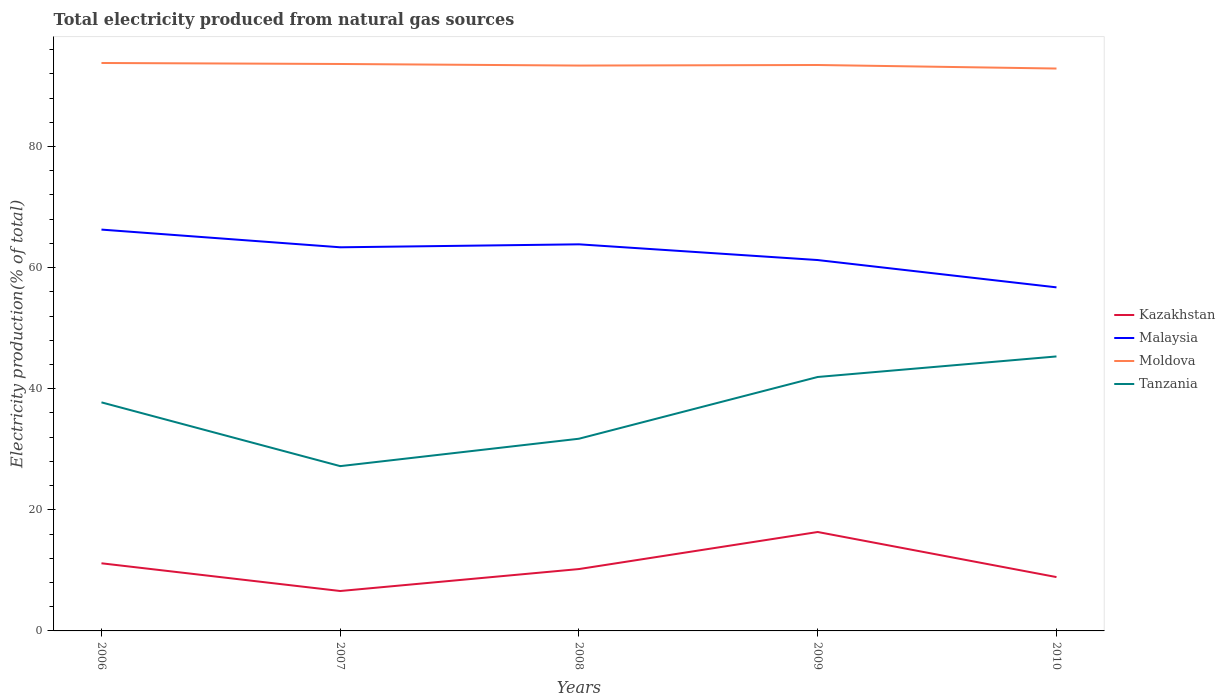Does the line corresponding to Malaysia intersect with the line corresponding to Moldova?
Give a very brief answer. No. Is the number of lines equal to the number of legend labels?
Provide a short and direct response. Yes. Across all years, what is the maximum total electricity produced in Malaysia?
Make the answer very short. 56.73. In which year was the total electricity produced in Tanzania maximum?
Provide a succinct answer. 2007. What is the total total electricity produced in Tanzania in the graph?
Your answer should be very brief. -3.39. What is the difference between the highest and the second highest total electricity produced in Tanzania?
Provide a succinct answer. 18.11. Is the total electricity produced in Tanzania strictly greater than the total electricity produced in Moldova over the years?
Offer a terse response. Yes. How many lines are there?
Your answer should be very brief. 4. How many years are there in the graph?
Give a very brief answer. 5. Are the values on the major ticks of Y-axis written in scientific E-notation?
Ensure brevity in your answer.  No. Does the graph contain grids?
Your answer should be very brief. No. How are the legend labels stacked?
Make the answer very short. Vertical. What is the title of the graph?
Offer a very short reply. Total electricity produced from natural gas sources. Does "Burkina Faso" appear as one of the legend labels in the graph?
Your response must be concise. No. What is the label or title of the X-axis?
Your answer should be very brief. Years. What is the Electricity production(% of total) in Kazakhstan in 2006?
Provide a short and direct response. 11.17. What is the Electricity production(% of total) of Malaysia in 2006?
Provide a succinct answer. 66.27. What is the Electricity production(% of total) of Moldova in 2006?
Ensure brevity in your answer.  93.78. What is the Electricity production(% of total) of Tanzania in 2006?
Give a very brief answer. 37.74. What is the Electricity production(% of total) of Kazakhstan in 2007?
Keep it short and to the point. 6.59. What is the Electricity production(% of total) of Malaysia in 2007?
Provide a short and direct response. 63.35. What is the Electricity production(% of total) of Moldova in 2007?
Offer a very short reply. 93.62. What is the Electricity production(% of total) of Tanzania in 2007?
Your answer should be very brief. 27.21. What is the Electricity production(% of total) in Kazakhstan in 2008?
Offer a very short reply. 10.22. What is the Electricity production(% of total) in Malaysia in 2008?
Provide a short and direct response. 63.84. What is the Electricity production(% of total) of Moldova in 2008?
Keep it short and to the point. 93.36. What is the Electricity production(% of total) of Tanzania in 2008?
Keep it short and to the point. 31.74. What is the Electricity production(% of total) in Kazakhstan in 2009?
Offer a very short reply. 16.33. What is the Electricity production(% of total) in Malaysia in 2009?
Ensure brevity in your answer.  61.24. What is the Electricity production(% of total) in Moldova in 2009?
Your answer should be very brief. 93.45. What is the Electricity production(% of total) in Tanzania in 2009?
Keep it short and to the point. 41.93. What is the Electricity production(% of total) of Kazakhstan in 2010?
Keep it short and to the point. 8.89. What is the Electricity production(% of total) of Malaysia in 2010?
Offer a very short reply. 56.73. What is the Electricity production(% of total) in Moldova in 2010?
Your answer should be compact. 92.87. What is the Electricity production(% of total) of Tanzania in 2010?
Provide a succinct answer. 45.32. Across all years, what is the maximum Electricity production(% of total) of Kazakhstan?
Ensure brevity in your answer.  16.33. Across all years, what is the maximum Electricity production(% of total) in Malaysia?
Keep it short and to the point. 66.27. Across all years, what is the maximum Electricity production(% of total) in Moldova?
Offer a very short reply. 93.78. Across all years, what is the maximum Electricity production(% of total) in Tanzania?
Offer a terse response. 45.32. Across all years, what is the minimum Electricity production(% of total) in Kazakhstan?
Your answer should be compact. 6.59. Across all years, what is the minimum Electricity production(% of total) in Malaysia?
Provide a succinct answer. 56.73. Across all years, what is the minimum Electricity production(% of total) in Moldova?
Your response must be concise. 92.87. Across all years, what is the minimum Electricity production(% of total) in Tanzania?
Your answer should be very brief. 27.21. What is the total Electricity production(% of total) of Kazakhstan in the graph?
Keep it short and to the point. 53.2. What is the total Electricity production(% of total) in Malaysia in the graph?
Keep it short and to the point. 311.43. What is the total Electricity production(% of total) of Moldova in the graph?
Your answer should be very brief. 467.08. What is the total Electricity production(% of total) in Tanzania in the graph?
Your response must be concise. 183.95. What is the difference between the Electricity production(% of total) of Kazakhstan in 2006 and that in 2007?
Make the answer very short. 4.58. What is the difference between the Electricity production(% of total) in Malaysia in 2006 and that in 2007?
Offer a terse response. 2.92. What is the difference between the Electricity production(% of total) of Moldova in 2006 and that in 2007?
Your answer should be very brief. 0.17. What is the difference between the Electricity production(% of total) in Tanzania in 2006 and that in 2007?
Your answer should be very brief. 10.53. What is the difference between the Electricity production(% of total) of Kazakhstan in 2006 and that in 2008?
Offer a terse response. 0.95. What is the difference between the Electricity production(% of total) of Malaysia in 2006 and that in 2008?
Give a very brief answer. 2.43. What is the difference between the Electricity production(% of total) in Moldova in 2006 and that in 2008?
Your answer should be compact. 0.43. What is the difference between the Electricity production(% of total) of Tanzania in 2006 and that in 2008?
Give a very brief answer. 6.01. What is the difference between the Electricity production(% of total) of Kazakhstan in 2006 and that in 2009?
Offer a terse response. -5.17. What is the difference between the Electricity production(% of total) in Malaysia in 2006 and that in 2009?
Provide a short and direct response. 5.03. What is the difference between the Electricity production(% of total) in Moldova in 2006 and that in 2009?
Your response must be concise. 0.33. What is the difference between the Electricity production(% of total) in Tanzania in 2006 and that in 2009?
Offer a terse response. -4.19. What is the difference between the Electricity production(% of total) in Kazakhstan in 2006 and that in 2010?
Make the answer very short. 2.28. What is the difference between the Electricity production(% of total) of Malaysia in 2006 and that in 2010?
Keep it short and to the point. 9.54. What is the difference between the Electricity production(% of total) of Moldova in 2006 and that in 2010?
Your response must be concise. 0.92. What is the difference between the Electricity production(% of total) in Tanzania in 2006 and that in 2010?
Ensure brevity in your answer.  -7.58. What is the difference between the Electricity production(% of total) in Kazakhstan in 2007 and that in 2008?
Provide a short and direct response. -3.63. What is the difference between the Electricity production(% of total) of Malaysia in 2007 and that in 2008?
Ensure brevity in your answer.  -0.49. What is the difference between the Electricity production(% of total) of Moldova in 2007 and that in 2008?
Provide a short and direct response. 0.26. What is the difference between the Electricity production(% of total) of Tanzania in 2007 and that in 2008?
Provide a succinct answer. -4.53. What is the difference between the Electricity production(% of total) of Kazakhstan in 2007 and that in 2009?
Ensure brevity in your answer.  -9.74. What is the difference between the Electricity production(% of total) of Malaysia in 2007 and that in 2009?
Your answer should be compact. 2.11. What is the difference between the Electricity production(% of total) in Moldova in 2007 and that in 2009?
Offer a very short reply. 0.17. What is the difference between the Electricity production(% of total) of Tanzania in 2007 and that in 2009?
Provide a succinct answer. -14.72. What is the difference between the Electricity production(% of total) of Kazakhstan in 2007 and that in 2010?
Offer a terse response. -2.3. What is the difference between the Electricity production(% of total) of Malaysia in 2007 and that in 2010?
Make the answer very short. 6.62. What is the difference between the Electricity production(% of total) of Moldova in 2007 and that in 2010?
Your answer should be compact. 0.75. What is the difference between the Electricity production(% of total) of Tanzania in 2007 and that in 2010?
Your response must be concise. -18.11. What is the difference between the Electricity production(% of total) in Kazakhstan in 2008 and that in 2009?
Offer a terse response. -6.12. What is the difference between the Electricity production(% of total) of Malaysia in 2008 and that in 2009?
Give a very brief answer. 2.6. What is the difference between the Electricity production(% of total) in Moldova in 2008 and that in 2009?
Give a very brief answer. -0.09. What is the difference between the Electricity production(% of total) of Tanzania in 2008 and that in 2009?
Ensure brevity in your answer.  -10.2. What is the difference between the Electricity production(% of total) of Kazakhstan in 2008 and that in 2010?
Your answer should be very brief. 1.33. What is the difference between the Electricity production(% of total) of Malaysia in 2008 and that in 2010?
Make the answer very short. 7.11. What is the difference between the Electricity production(% of total) of Moldova in 2008 and that in 2010?
Offer a terse response. 0.49. What is the difference between the Electricity production(% of total) in Tanzania in 2008 and that in 2010?
Offer a very short reply. -13.59. What is the difference between the Electricity production(% of total) of Kazakhstan in 2009 and that in 2010?
Keep it short and to the point. 7.44. What is the difference between the Electricity production(% of total) of Malaysia in 2009 and that in 2010?
Provide a short and direct response. 4.51. What is the difference between the Electricity production(% of total) in Moldova in 2009 and that in 2010?
Your answer should be compact. 0.58. What is the difference between the Electricity production(% of total) in Tanzania in 2009 and that in 2010?
Provide a short and direct response. -3.39. What is the difference between the Electricity production(% of total) of Kazakhstan in 2006 and the Electricity production(% of total) of Malaysia in 2007?
Your answer should be very brief. -52.18. What is the difference between the Electricity production(% of total) in Kazakhstan in 2006 and the Electricity production(% of total) in Moldova in 2007?
Provide a succinct answer. -82.45. What is the difference between the Electricity production(% of total) of Kazakhstan in 2006 and the Electricity production(% of total) of Tanzania in 2007?
Provide a succinct answer. -16.04. What is the difference between the Electricity production(% of total) of Malaysia in 2006 and the Electricity production(% of total) of Moldova in 2007?
Make the answer very short. -27.35. What is the difference between the Electricity production(% of total) in Malaysia in 2006 and the Electricity production(% of total) in Tanzania in 2007?
Offer a very short reply. 39.06. What is the difference between the Electricity production(% of total) of Moldova in 2006 and the Electricity production(% of total) of Tanzania in 2007?
Your response must be concise. 66.57. What is the difference between the Electricity production(% of total) in Kazakhstan in 2006 and the Electricity production(% of total) in Malaysia in 2008?
Keep it short and to the point. -52.67. What is the difference between the Electricity production(% of total) of Kazakhstan in 2006 and the Electricity production(% of total) of Moldova in 2008?
Provide a short and direct response. -82.19. What is the difference between the Electricity production(% of total) in Kazakhstan in 2006 and the Electricity production(% of total) in Tanzania in 2008?
Keep it short and to the point. -20.57. What is the difference between the Electricity production(% of total) of Malaysia in 2006 and the Electricity production(% of total) of Moldova in 2008?
Offer a very short reply. -27.09. What is the difference between the Electricity production(% of total) of Malaysia in 2006 and the Electricity production(% of total) of Tanzania in 2008?
Offer a very short reply. 34.53. What is the difference between the Electricity production(% of total) of Moldova in 2006 and the Electricity production(% of total) of Tanzania in 2008?
Give a very brief answer. 62.05. What is the difference between the Electricity production(% of total) in Kazakhstan in 2006 and the Electricity production(% of total) in Malaysia in 2009?
Provide a short and direct response. -50.07. What is the difference between the Electricity production(% of total) in Kazakhstan in 2006 and the Electricity production(% of total) in Moldova in 2009?
Your answer should be compact. -82.28. What is the difference between the Electricity production(% of total) in Kazakhstan in 2006 and the Electricity production(% of total) in Tanzania in 2009?
Provide a short and direct response. -30.77. What is the difference between the Electricity production(% of total) of Malaysia in 2006 and the Electricity production(% of total) of Moldova in 2009?
Your answer should be compact. -27.18. What is the difference between the Electricity production(% of total) in Malaysia in 2006 and the Electricity production(% of total) in Tanzania in 2009?
Ensure brevity in your answer.  24.34. What is the difference between the Electricity production(% of total) in Moldova in 2006 and the Electricity production(% of total) in Tanzania in 2009?
Your answer should be compact. 51.85. What is the difference between the Electricity production(% of total) of Kazakhstan in 2006 and the Electricity production(% of total) of Malaysia in 2010?
Keep it short and to the point. -45.56. What is the difference between the Electricity production(% of total) of Kazakhstan in 2006 and the Electricity production(% of total) of Moldova in 2010?
Ensure brevity in your answer.  -81.7. What is the difference between the Electricity production(% of total) in Kazakhstan in 2006 and the Electricity production(% of total) in Tanzania in 2010?
Offer a terse response. -34.16. What is the difference between the Electricity production(% of total) of Malaysia in 2006 and the Electricity production(% of total) of Moldova in 2010?
Your answer should be compact. -26.6. What is the difference between the Electricity production(% of total) in Malaysia in 2006 and the Electricity production(% of total) in Tanzania in 2010?
Provide a succinct answer. 20.95. What is the difference between the Electricity production(% of total) of Moldova in 2006 and the Electricity production(% of total) of Tanzania in 2010?
Your answer should be compact. 48.46. What is the difference between the Electricity production(% of total) of Kazakhstan in 2007 and the Electricity production(% of total) of Malaysia in 2008?
Ensure brevity in your answer.  -57.25. What is the difference between the Electricity production(% of total) of Kazakhstan in 2007 and the Electricity production(% of total) of Moldova in 2008?
Your answer should be compact. -86.77. What is the difference between the Electricity production(% of total) of Kazakhstan in 2007 and the Electricity production(% of total) of Tanzania in 2008?
Keep it short and to the point. -25.15. What is the difference between the Electricity production(% of total) of Malaysia in 2007 and the Electricity production(% of total) of Moldova in 2008?
Provide a short and direct response. -30.01. What is the difference between the Electricity production(% of total) of Malaysia in 2007 and the Electricity production(% of total) of Tanzania in 2008?
Offer a very short reply. 31.61. What is the difference between the Electricity production(% of total) in Moldova in 2007 and the Electricity production(% of total) in Tanzania in 2008?
Make the answer very short. 61.88. What is the difference between the Electricity production(% of total) in Kazakhstan in 2007 and the Electricity production(% of total) in Malaysia in 2009?
Your response must be concise. -54.65. What is the difference between the Electricity production(% of total) of Kazakhstan in 2007 and the Electricity production(% of total) of Moldova in 2009?
Give a very brief answer. -86.86. What is the difference between the Electricity production(% of total) of Kazakhstan in 2007 and the Electricity production(% of total) of Tanzania in 2009?
Your answer should be very brief. -35.34. What is the difference between the Electricity production(% of total) of Malaysia in 2007 and the Electricity production(% of total) of Moldova in 2009?
Your response must be concise. -30.1. What is the difference between the Electricity production(% of total) in Malaysia in 2007 and the Electricity production(% of total) in Tanzania in 2009?
Give a very brief answer. 21.41. What is the difference between the Electricity production(% of total) of Moldova in 2007 and the Electricity production(% of total) of Tanzania in 2009?
Ensure brevity in your answer.  51.68. What is the difference between the Electricity production(% of total) of Kazakhstan in 2007 and the Electricity production(% of total) of Malaysia in 2010?
Keep it short and to the point. -50.14. What is the difference between the Electricity production(% of total) of Kazakhstan in 2007 and the Electricity production(% of total) of Moldova in 2010?
Give a very brief answer. -86.28. What is the difference between the Electricity production(% of total) of Kazakhstan in 2007 and the Electricity production(% of total) of Tanzania in 2010?
Ensure brevity in your answer.  -38.73. What is the difference between the Electricity production(% of total) of Malaysia in 2007 and the Electricity production(% of total) of Moldova in 2010?
Offer a terse response. -29.52. What is the difference between the Electricity production(% of total) of Malaysia in 2007 and the Electricity production(% of total) of Tanzania in 2010?
Give a very brief answer. 18.02. What is the difference between the Electricity production(% of total) in Moldova in 2007 and the Electricity production(% of total) in Tanzania in 2010?
Provide a short and direct response. 48.29. What is the difference between the Electricity production(% of total) of Kazakhstan in 2008 and the Electricity production(% of total) of Malaysia in 2009?
Offer a very short reply. -51.03. What is the difference between the Electricity production(% of total) of Kazakhstan in 2008 and the Electricity production(% of total) of Moldova in 2009?
Your answer should be compact. -83.23. What is the difference between the Electricity production(% of total) of Kazakhstan in 2008 and the Electricity production(% of total) of Tanzania in 2009?
Make the answer very short. -31.72. What is the difference between the Electricity production(% of total) in Malaysia in 2008 and the Electricity production(% of total) in Moldova in 2009?
Ensure brevity in your answer.  -29.61. What is the difference between the Electricity production(% of total) in Malaysia in 2008 and the Electricity production(% of total) in Tanzania in 2009?
Offer a very short reply. 21.9. What is the difference between the Electricity production(% of total) in Moldova in 2008 and the Electricity production(% of total) in Tanzania in 2009?
Your answer should be very brief. 51.42. What is the difference between the Electricity production(% of total) in Kazakhstan in 2008 and the Electricity production(% of total) in Malaysia in 2010?
Provide a succinct answer. -46.52. What is the difference between the Electricity production(% of total) of Kazakhstan in 2008 and the Electricity production(% of total) of Moldova in 2010?
Provide a short and direct response. -82.65. What is the difference between the Electricity production(% of total) in Kazakhstan in 2008 and the Electricity production(% of total) in Tanzania in 2010?
Your answer should be very brief. -35.11. What is the difference between the Electricity production(% of total) in Malaysia in 2008 and the Electricity production(% of total) in Moldova in 2010?
Make the answer very short. -29.03. What is the difference between the Electricity production(% of total) in Malaysia in 2008 and the Electricity production(% of total) in Tanzania in 2010?
Your response must be concise. 18.51. What is the difference between the Electricity production(% of total) in Moldova in 2008 and the Electricity production(% of total) in Tanzania in 2010?
Your response must be concise. 48.03. What is the difference between the Electricity production(% of total) of Kazakhstan in 2009 and the Electricity production(% of total) of Malaysia in 2010?
Your response must be concise. -40.4. What is the difference between the Electricity production(% of total) in Kazakhstan in 2009 and the Electricity production(% of total) in Moldova in 2010?
Give a very brief answer. -76.53. What is the difference between the Electricity production(% of total) in Kazakhstan in 2009 and the Electricity production(% of total) in Tanzania in 2010?
Offer a terse response. -28.99. What is the difference between the Electricity production(% of total) of Malaysia in 2009 and the Electricity production(% of total) of Moldova in 2010?
Provide a succinct answer. -31.63. What is the difference between the Electricity production(% of total) of Malaysia in 2009 and the Electricity production(% of total) of Tanzania in 2010?
Give a very brief answer. 15.92. What is the difference between the Electricity production(% of total) in Moldova in 2009 and the Electricity production(% of total) in Tanzania in 2010?
Keep it short and to the point. 48.12. What is the average Electricity production(% of total) in Kazakhstan per year?
Give a very brief answer. 10.64. What is the average Electricity production(% of total) of Malaysia per year?
Ensure brevity in your answer.  62.29. What is the average Electricity production(% of total) of Moldova per year?
Provide a succinct answer. 93.42. What is the average Electricity production(% of total) in Tanzania per year?
Make the answer very short. 36.79. In the year 2006, what is the difference between the Electricity production(% of total) of Kazakhstan and Electricity production(% of total) of Malaysia?
Your answer should be very brief. -55.1. In the year 2006, what is the difference between the Electricity production(% of total) in Kazakhstan and Electricity production(% of total) in Moldova?
Offer a terse response. -82.62. In the year 2006, what is the difference between the Electricity production(% of total) of Kazakhstan and Electricity production(% of total) of Tanzania?
Ensure brevity in your answer.  -26.57. In the year 2006, what is the difference between the Electricity production(% of total) of Malaysia and Electricity production(% of total) of Moldova?
Offer a terse response. -27.51. In the year 2006, what is the difference between the Electricity production(% of total) of Malaysia and Electricity production(% of total) of Tanzania?
Give a very brief answer. 28.53. In the year 2006, what is the difference between the Electricity production(% of total) of Moldova and Electricity production(% of total) of Tanzania?
Your answer should be very brief. 56.04. In the year 2007, what is the difference between the Electricity production(% of total) of Kazakhstan and Electricity production(% of total) of Malaysia?
Offer a terse response. -56.76. In the year 2007, what is the difference between the Electricity production(% of total) in Kazakhstan and Electricity production(% of total) in Moldova?
Keep it short and to the point. -87.03. In the year 2007, what is the difference between the Electricity production(% of total) in Kazakhstan and Electricity production(% of total) in Tanzania?
Your answer should be compact. -20.62. In the year 2007, what is the difference between the Electricity production(% of total) in Malaysia and Electricity production(% of total) in Moldova?
Your answer should be compact. -30.27. In the year 2007, what is the difference between the Electricity production(% of total) of Malaysia and Electricity production(% of total) of Tanzania?
Ensure brevity in your answer.  36.14. In the year 2007, what is the difference between the Electricity production(% of total) in Moldova and Electricity production(% of total) in Tanzania?
Offer a very short reply. 66.4. In the year 2008, what is the difference between the Electricity production(% of total) of Kazakhstan and Electricity production(% of total) of Malaysia?
Ensure brevity in your answer.  -53.62. In the year 2008, what is the difference between the Electricity production(% of total) of Kazakhstan and Electricity production(% of total) of Moldova?
Your response must be concise. -83.14. In the year 2008, what is the difference between the Electricity production(% of total) of Kazakhstan and Electricity production(% of total) of Tanzania?
Your answer should be compact. -21.52. In the year 2008, what is the difference between the Electricity production(% of total) of Malaysia and Electricity production(% of total) of Moldova?
Your answer should be compact. -29.52. In the year 2008, what is the difference between the Electricity production(% of total) in Malaysia and Electricity production(% of total) in Tanzania?
Ensure brevity in your answer.  32.1. In the year 2008, what is the difference between the Electricity production(% of total) of Moldova and Electricity production(% of total) of Tanzania?
Offer a very short reply. 61.62. In the year 2009, what is the difference between the Electricity production(% of total) of Kazakhstan and Electricity production(% of total) of Malaysia?
Give a very brief answer. -44.91. In the year 2009, what is the difference between the Electricity production(% of total) in Kazakhstan and Electricity production(% of total) in Moldova?
Your answer should be very brief. -77.11. In the year 2009, what is the difference between the Electricity production(% of total) in Kazakhstan and Electricity production(% of total) in Tanzania?
Give a very brief answer. -25.6. In the year 2009, what is the difference between the Electricity production(% of total) of Malaysia and Electricity production(% of total) of Moldova?
Provide a short and direct response. -32.21. In the year 2009, what is the difference between the Electricity production(% of total) in Malaysia and Electricity production(% of total) in Tanzania?
Give a very brief answer. 19.31. In the year 2009, what is the difference between the Electricity production(% of total) of Moldova and Electricity production(% of total) of Tanzania?
Make the answer very short. 51.52. In the year 2010, what is the difference between the Electricity production(% of total) of Kazakhstan and Electricity production(% of total) of Malaysia?
Provide a short and direct response. -47.84. In the year 2010, what is the difference between the Electricity production(% of total) of Kazakhstan and Electricity production(% of total) of Moldova?
Your response must be concise. -83.98. In the year 2010, what is the difference between the Electricity production(% of total) in Kazakhstan and Electricity production(% of total) in Tanzania?
Provide a short and direct response. -36.44. In the year 2010, what is the difference between the Electricity production(% of total) of Malaysia and Electricity production(% of total) of Moldova?
Provide a short and direct response. -36.13. In the year 2010, what is the difference between the Electricity production(% of total) of Malaysia and Electricity production(% of total) of Tanzania?
Provide a short and direct response. 11.41. In the year 2010, what is the difference between the Electricity production(% of total) in Moldova and Electricity production(% of total) in Tanzania?
Give a very brief answer. 47.54. What is the ratio of the Electricity production(% of total) in Kazakhstan in 2006 to that in 2007?
Your answer should be compact. 1.69. What is the ratio of the Electricity production(% of total) of Malaysia in 2006 to that in 2007?
Ensure brevity in your answer.  1.05. What is the ratio of the Electricity production(% of total) of Tanzania in 2006 to that in 2007?
Make the answer very short. 1.39. What is the ratio of the Electricity production(% of total) in Kazakhstan in 2006 to that in 2008?
Make the answer very short. 1.09. What is the ratio of the Electricity production(% of total) of Malaysia in 2006 to that in 2008?
Offer a terse response. 1.04. What is the ratio of the Electricity production(% of total) of Tanzania in 2006 to that in 2008?
Offer a very short reply. 1.19. What is the ratio of the Electricity production(% of total) in Kazakhstan in 2006 to that in 2009?
Your answer should be compact. 0.68. What is the ratio of the Electricity production(% of total) of Malaysia in 2006 to that in 2009?
Ensure brevity in your answer.  1.08. What is the ratio of the Electricity production(% of total) in Moldova in 2006 to that in 2009?
Make the answer very short. 1. What is the ratio of the Electricity production(% of total) of Tanzania in 2006 to that in 2009?
Keep it short and to the point. 0.9. What is the ratio of the Electricity production(% of total) of Kazakhstan in 2006 to that in 2010?
Your answer should be very brief. 1.26. What is the ratio of the Electricity production(% of total) in Malaysia in 2006 to that in 2010?
Give a very brief answer. 1.17. What is the ratio of the Electricity production(% of total) of Moldova in 2006 to that in 2010?
Your answer should be compact. 1.01. What is the ratio of the Electricity production(% of total) in Tanzania in 2006 to that in 2010?
Give a very brief answer. 0.83. What is the ratio of the Electricity production(% of total) in Kazakhstan in 2007 to that in 2008?
Your response must be concise. 0.65. What is the ratio of the Electricity production(% of total) in Moldova in 2007 to that in 2008?
Provide a short and direct response. 1. What is the ratio of the Electricity production(% of total) in Tanzania in 2007 to that in 2008?
Your answer should be compact. 0.86. What is the ratio of the Electricity production(% of total) of Kazakhstan in 2007 to that in 2009?
Your answer should be compact. 0.4. What is the ratio of the Electricity production(% of total) of Malaysia in 2007 to that in 2009?
Keep it short and to the point. 1.03. What is the ratio of the Electricity production(% of total) of Moldova in 2007 to that in 2009?
Your answer should be very brief. 1. What is the ratio of the Electricity production(% of total) in Tanzania in 2007 to that in 2009?
Ensure brevity in your answer.  0.65. What is the ratio of the Electricity production(% of total) of Kazakhstan in 2007 to that in 2010?
Your answer should be compact. 0.74. What is the ratio of the Electricity production(% of total) in Malaysia in 2007 to that in 2010?
Provide a succinct answer. 1.12. What is the ratio of the Electricity production(% of total) of Tanzania in 2007 to that in 2010?
Your response must be concise. 0.6. What is the ratio of the Electricity production(% of total) in Kazakhstan in 2008 to that in 2009?
Your answer should be compact. 0.63. What is the ratio of the Electricity production(% of total) of Malaysia in 2008 to that in 2009?
Make the answer very short. 1.04. What is the ratio of the Electricity production(% of total) in Moldova in 2008 to that in 2009?
Provide a short and direct response. 1. What is the ratio of the Electricity production(% of total) in Tanzania in 2008 to that in 2009?
Provide a short and direct response. 0.76. What is the ratio of the Electricity production(% of total) of Kazakhstan in 2008 to that in 2010?
Ensure brevity in your answer.  1.15. What is the ratio of the Electricity production(% of total) of Malaysia in 2008 to that in 2010?
Your response must be concise. 1.13. What is the ratio of the Electricity production(% of total) in Tanzania in 2008 to that in 2010?
Give a very brief answer. 0.7. What is the ratio of the Electricity production(% of total) in Kazakhstan in 2009 to that in 2010?
Your answer should be compact. 1.84. What is the ratio of the Electricity production(% of total) in Malaysia in 2009 to that in 2010?
Offer a terse response. 1.08. What is the ratio of the Electricity production(% of total) of Tanzania in 2009 to that in 2010?
Your answer should be very brief. 0.93. What is the difference between the highest and the second highest Electricity production(% of total) in Kazakhstan?
Your response must be concise. 5.17. What is the difference between the highest and the second highest Electricity production(% of total) of Malaysia?
Give a very brief answer. 2.43. What is the difference between the highest and the second highest Electricity production(% of total) of Moldova?
Your answer should be compact. 0.17. What is the difference between the highest and the second highest Electricity production(% of total) in Tanzania?
Give a very brief answer. 3.39. What is the difference between the highest and the lowest Electricity production(% of total) in Kazakhstan?
Your answer should be compact. 9.74. What is the difference between the highest and the lowest Electricity production(% of total) of Malaysia?
Provide a succinct answer. 9.54. What is the difference between the highest and the lowest Electricity production(% of total) in Moldova?
Your answer should be very brief. 0.92. What is the difference between the highest and the lowest Electricity production(% of total) in Tanzania?
Your answer should be very brief. 18.11. 